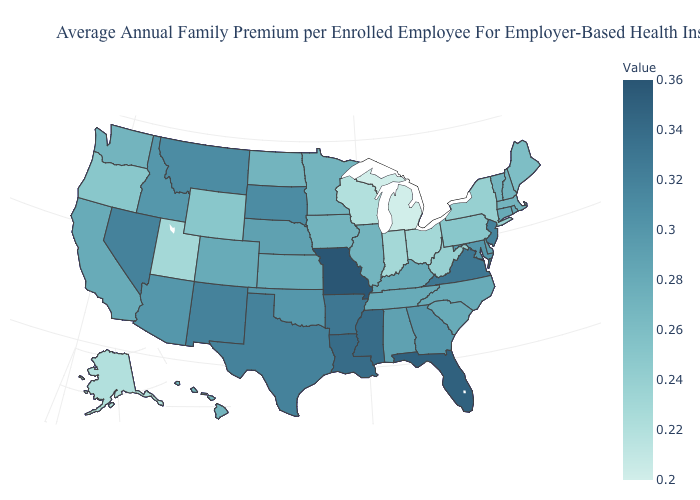Does Missouri have the highest value in the USA?
Concise answer only. Yes. Which states have the lowest value in the USA?
Give a very brief answer. Michigan. Among the states that border Louisiana , does Texas have the highest value?
Write a very short answer. No. Does California have a higher value than Oklahoma?
Write a very short answer. No. Does Michigan have the lowest value in the USA?
Quick response, please. Yes. Does the map have missing data?
Write a very short answer. No. 